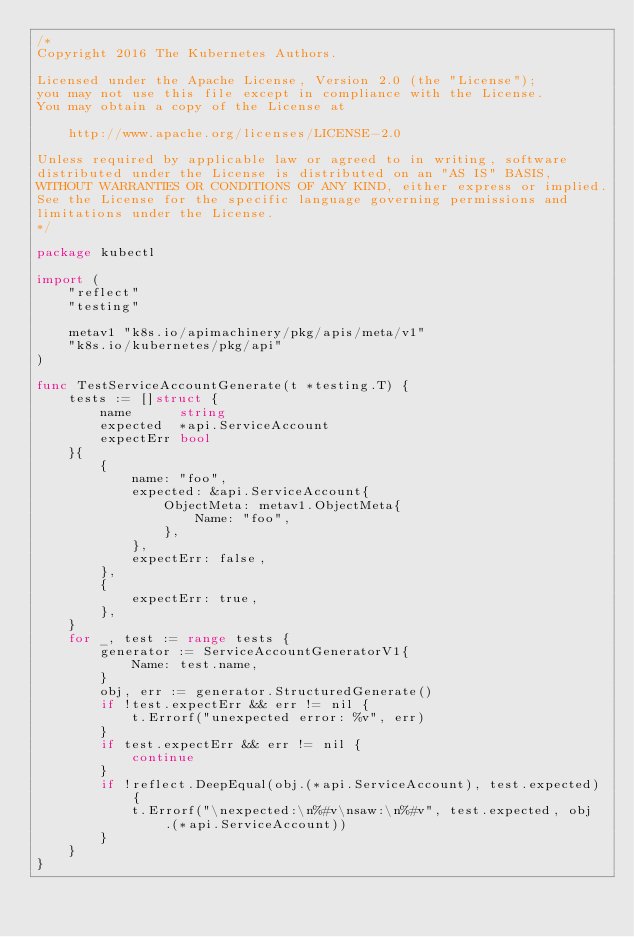<code> <loc_0><loc_0><loc_500><loc_500><_Go_>/*
Copyright 2016 The Kubernetes Authors.

Licensed under the Apache License, Version 2.0 (the "License");
you may not use this file except in compliance with the License.
You may obtain a copy of the License at

    http://www.apache.org/licenses/LICENSE-2.0

Unless required by applicable law or agreed to in writing, software
distributed under the License is distributed on an "AS IS" BASIS,
WITHOUT WARRANTIES OR CONDITIONS OF ANY KIND, either express or implied.
See the License for the specific language governing permissions and
limitations under the License.
*/

package kubectl

import (
	"reflect"
	"testing"

	metav1 "k8s.io/apimachinery/pkg/apis/meta/v1"
	"k8s.io/kubernetes/pkg/api"
)

func TestServiceAccountGenerate(t *testing.T) {
	tests := []struct {
		name      string
		expected  *api.ServiceAccount
		expectErr bool
	}{
		{
			name: "foo",
			expected: &api.ServiceAccount{
				ObjectMeta: metav1.ObjectMeta{
					Name: "foo",
				},
			},
			expectErr: false,
		},
		{
			expectErr: true,
		},
	}
	for _, test := range tests {
		generator := ServiceAccountGeneratorV1{
			Name: test.name,
		}
		obj, err := generator.StructuredGenerate()
		if !test.expectErr && err != nil {
			t.Errorf("unexpected error: %v", err)
		}
		if test.expectErr && err != nil {
			continue
		}
		if !reflect.DeepEqual(obj.(*api.ServiceAccount), test.expected) {
			t.Errorf("\nexpected:\n%#v\nsaw:\n%#v", test.expected, obj.(*api.ServiceAccount))
		}
	}
}
</code> 